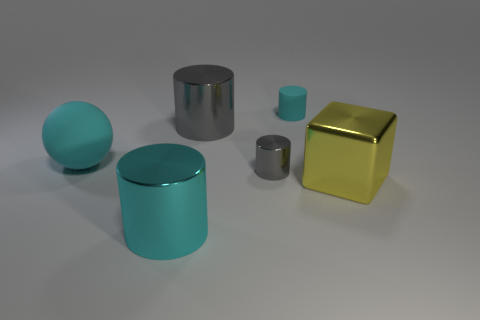Add 3 tiny objects. How many objects exist? 9 Subtract all large gray metallic cylinders. How many cylinders are left? 3 Subtract all cyan cylinders. How many cylinders are left? 2 Subtract 1 cubes. How many cubes are left? 0 Subtract all cylinders. How many objects are left? 2 Add 6 cyan things. How many cyan things are left? 9 Add 2 matte things. How many matte things exist? 4 Subtract 0 brown cubes. How many objects are left? 6 Subtract all gray cylinders. Subtract all blue balls. How many cylinders are left? 2 Subtract all red blocks. How many green spheres are left? 0 